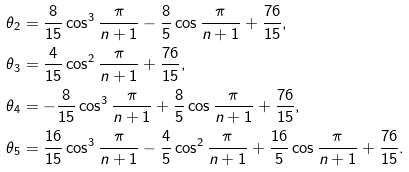Convert formula to latex. <formula><loc_0><loc_0><loc_500><loc_500>\theta _ { 2 } & = \frac { 8 } { 1 5 } \cos ^ { 3 } \frac { \pi } { n + 1 } - \frac { 8 } { 5 } \cos \frac { \pi } { n + 1 } + \frac { 7 6 } { 1 5 } , \\ \theta _ { 3 } & = \frac { 4 } { 1 5 } \cos ^ { 2 } \frac { \pi } { n + 1 } + \frac { 7 6 } { 1 5 } , \\ \theta _ { 4 } & = - \frac { 8 } { 1 5 } \cos ^ { 3 } \frac { \pi } { n + 1 } + \frac { 8 } { 5 } \cos \frac { \pi } { n + 1 } + \frac { 7 6 } { 1 5 } , \\ \theta _ { 5 } & = \frac { 1 6 } { 1 5 } \cos ^ { 3 } \frac { \pi } { n + 1 } - \frac { 4 } { 5 } \cos ^ { 2 } \frac { \pi } { n + 1 } + \frac { 1 6 } { 5 } \cos \frac { \pi } { n + 1 } + \frac { 7 6 } { 1 5 } .</formula> 